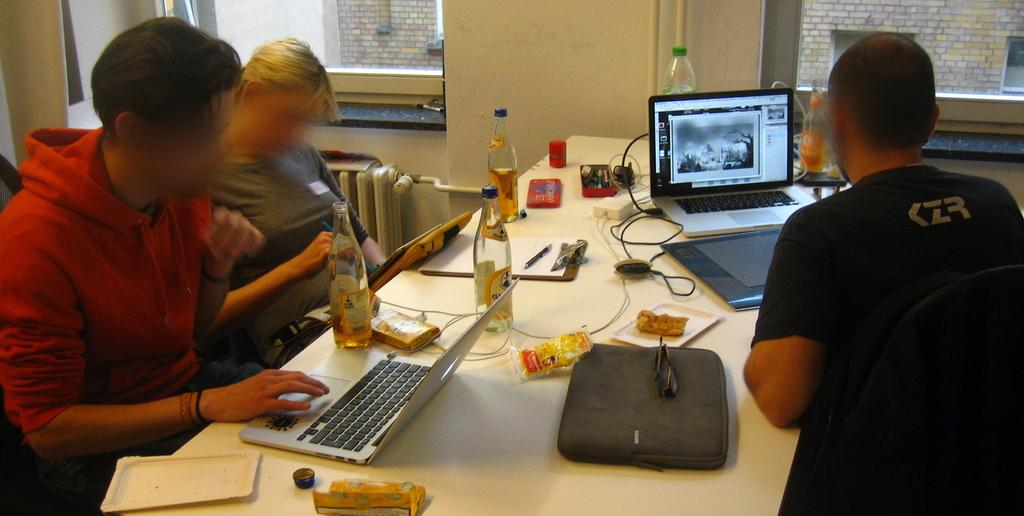<image>
Summarize the visual content of the image. Some people at a desk, one of whom has the letters CZR on his tee shirt. 